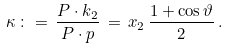Convert formula to latex. <formula><loc_0><loc_0><loc_500><loc_500>\kappa \, \colon = \, \frac { P \cdot k _ { 2 } } { P \cdot p } \, = \, x _ { 2 } \, \frac { 1 + \cos \vartheta } { 2 } \, .</formula> 